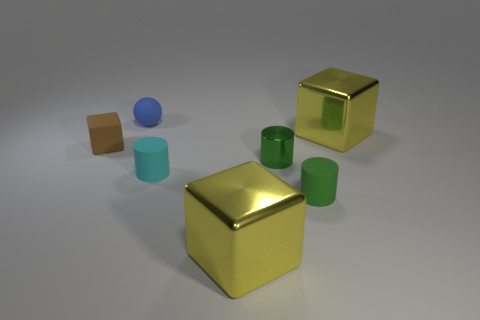Subtract all shiny cylinders. How many cylinders are left? 2 Add 3 brown cubes. How many objects exist? 10 Subtract all brown blocks. How many blocks are left? 2 Subtract all spheres. How many objects are left? 6 Subtract 1 cylinders. How many cylinders are left? 2 Subtract all brown cylinders. Subtract all blue blocks. How many cylinders are left? 3 Subtract all yellow cubes. How many blue cylinders are left? 0 Subtract all rubber balls. Subtract all small red matte objects. How many objects are left? 6 Add 1 tiny rubber objects. How many tiny rubber objects are left? 5 Add 3 small yellow cubes. How many small yellow cubes exist? 3 